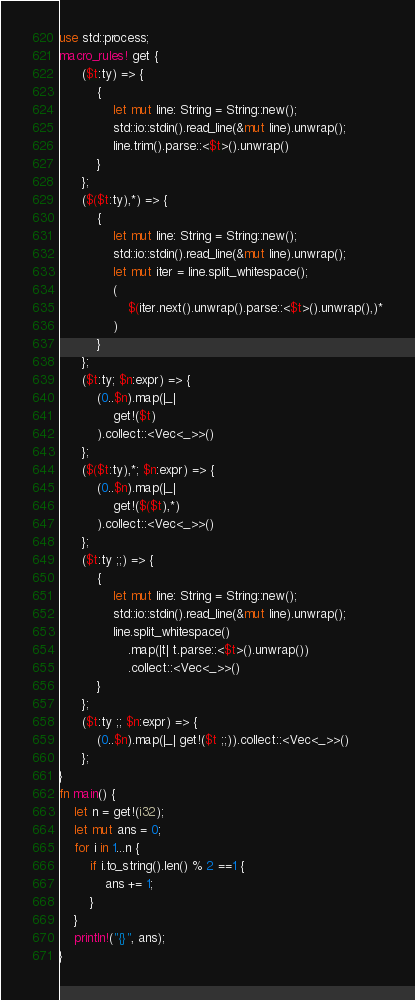<code> <loc_0><loc_0><loc_500><loc_500><_Rust_>use std::process;
macro_rules! get {
      ($t:ty) => {
          {
              let mut line: String = String::new();
              std::io::stdin().read_line(&mut line).unwrap();
              line.trim().parse::<$t>().unwrap()
          }
      };
      ($($t:ty),*) => {
          {
              let mut line: String = String::new();
              std::io::stdin().read_line(&mut line).unwrap();
              let mut iter = line.split_whitespace();
              (
                  $(iter.next().unwrap().parse::<$t>().unwrap(),)*
              )
          }
      };
      ($t:ty; $n:expr) => {
          (0..$n).map(|_|
              get!($t)
          ).collect::<Vec<_>>()
      };
      ($($t:ty),*; $n:expr) => {
          (0..$n).map(|_|
              get!($($t),*)
          ).collect::<Vec<_>>()
      };
      ($t:ty ;;) => {
          {
              let mut line: String = String::new();
              std::io::stdin().read_line(&mut line).unwrap();
              line.split_whitespace()
                  .map(|t| t.parse::<$t>().unwrap())
                  .collect::<Vec<_>>()
          }
      };
      ($t:ty ;; $n:expr) => {
          (0..$n).map(|_| get!($t ;;)).collect::<Vec<_>>()
      };
}
fn main() {
    let n = get!(i32);
    let mut ans = 0;
    for i in 1...n {
        if i.to_string().len() % 2 ==1 {
            ans += 1;
        }
    }
    println!("{}", ans);
}
</code> 